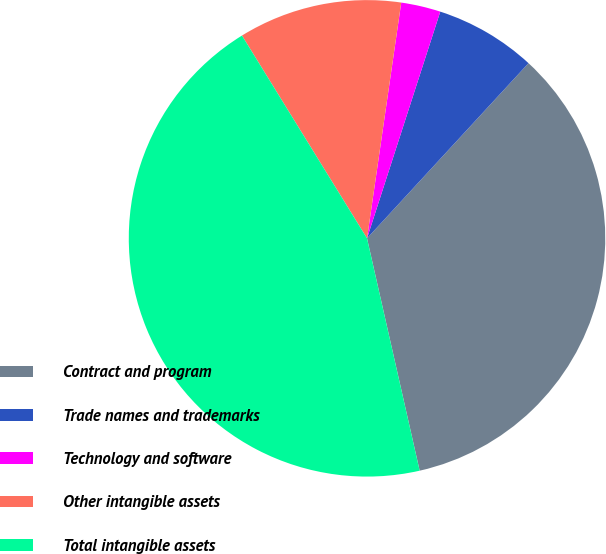<chart> <loc_0><loc_0><loc_500><loc_500><pie_chart><fcel>Contract and program<fcel>Trade names and trademarks<fcel>Technology and software<fcel>Other intangible assets<fcel>Total intangible assets<nl><fcel>34.6%<fcel>6.88%<fcel>2.68%<fcel>11.09%<fcel>44.75%<nl></chart> 